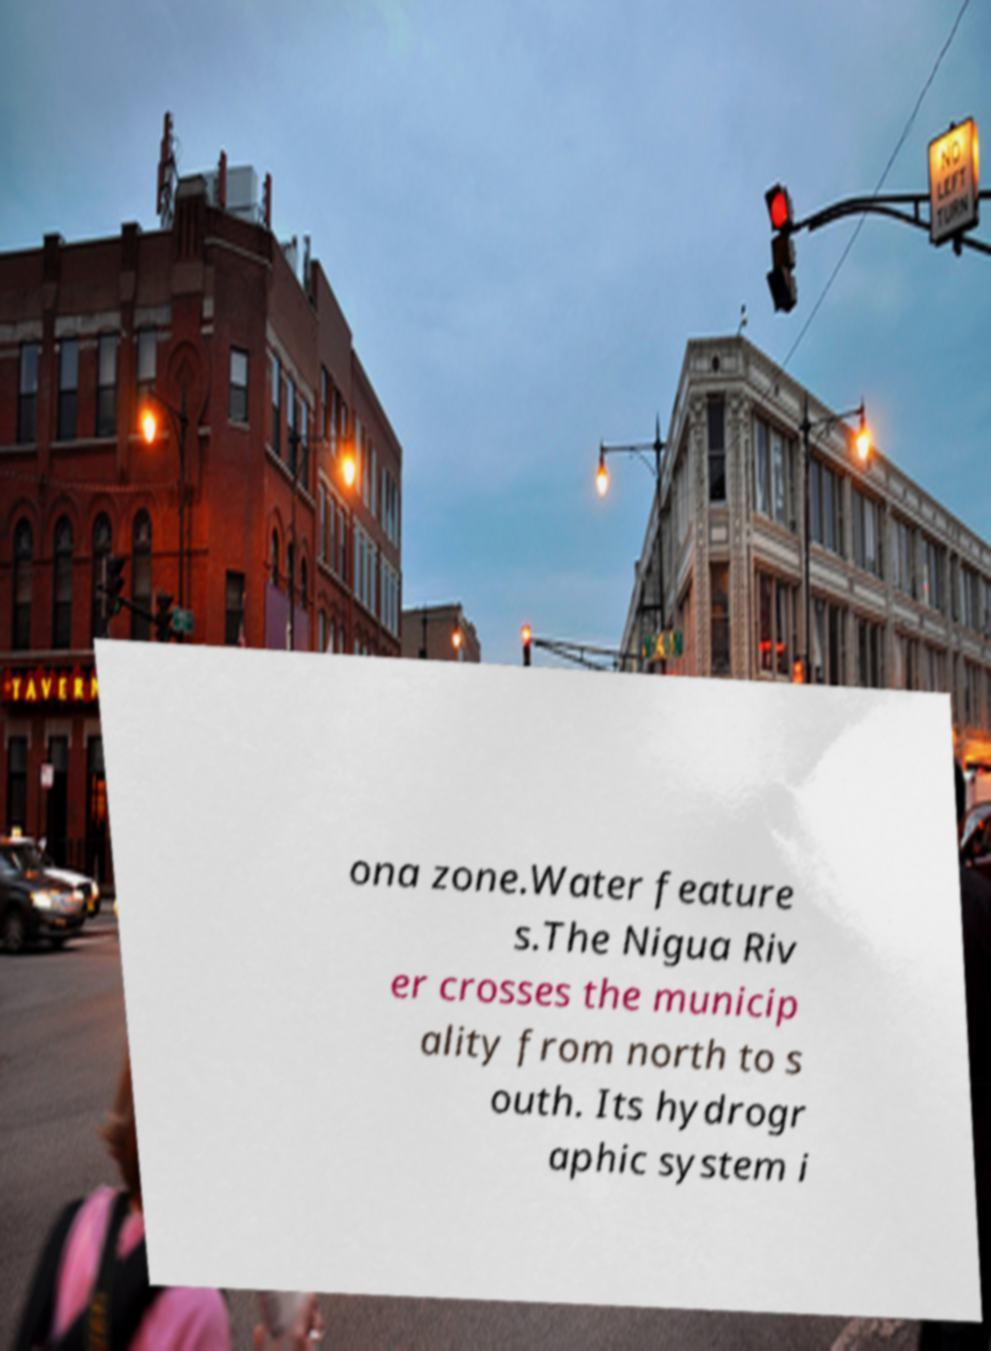What messages or text are displayed in this image? I need them in a readable, typed format. ona zone.Water feature s.The Nigua Riv er crosses the municip ality from north to s outh. Its hydrogr aphic system i 